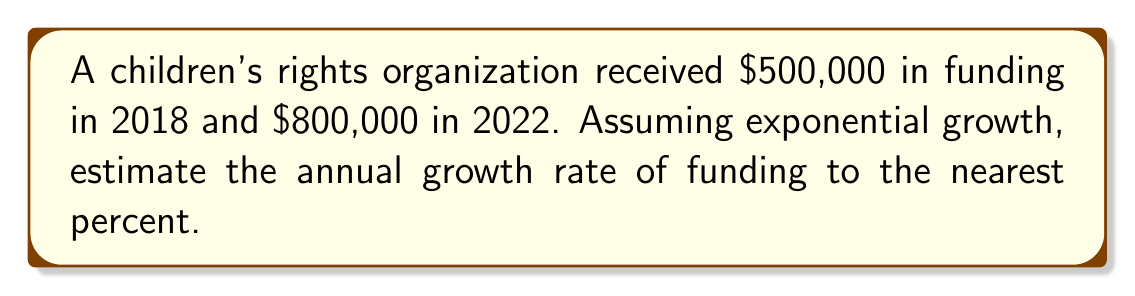What is the answer to this math problem? To estimate the annual growth rate, we can use the compound interest formula:

$$A = P(1 + r)^t$$

Where:
$A$ = Final amount
$P$ = Initial amount
$r$ = Annual growth rate
$t$ = Number of years

Given:
$P = 500,000$
$A = 800,000$
$t = 4$ years (2018 to 2022)

Step 1: Substitute the known values into the formula:
$$800,000 = 500,000(1 + r)^4$$

Step 2: Divide both sides by 500,000:
$$\frac{800,000}{500,000} = (1 + r)^4$$

Step 3: Simplify:
$$1.6 = (1 + r)^4$$

Step 4: Take the fourth root of both sides:
$$\sqrt[4]{1.6} = 1 + r$$

Step 5: Solve for r:
$$r = \sqrt[4]{1.6} - 1$$

Step 6: Calculate the value of r:
$$r \approx 0.1252$$

Step 7: Convert to a percentage and round to the nearest percent:
$$r \approx 12.52\% \approx 13\%$$
Answer: 13% 